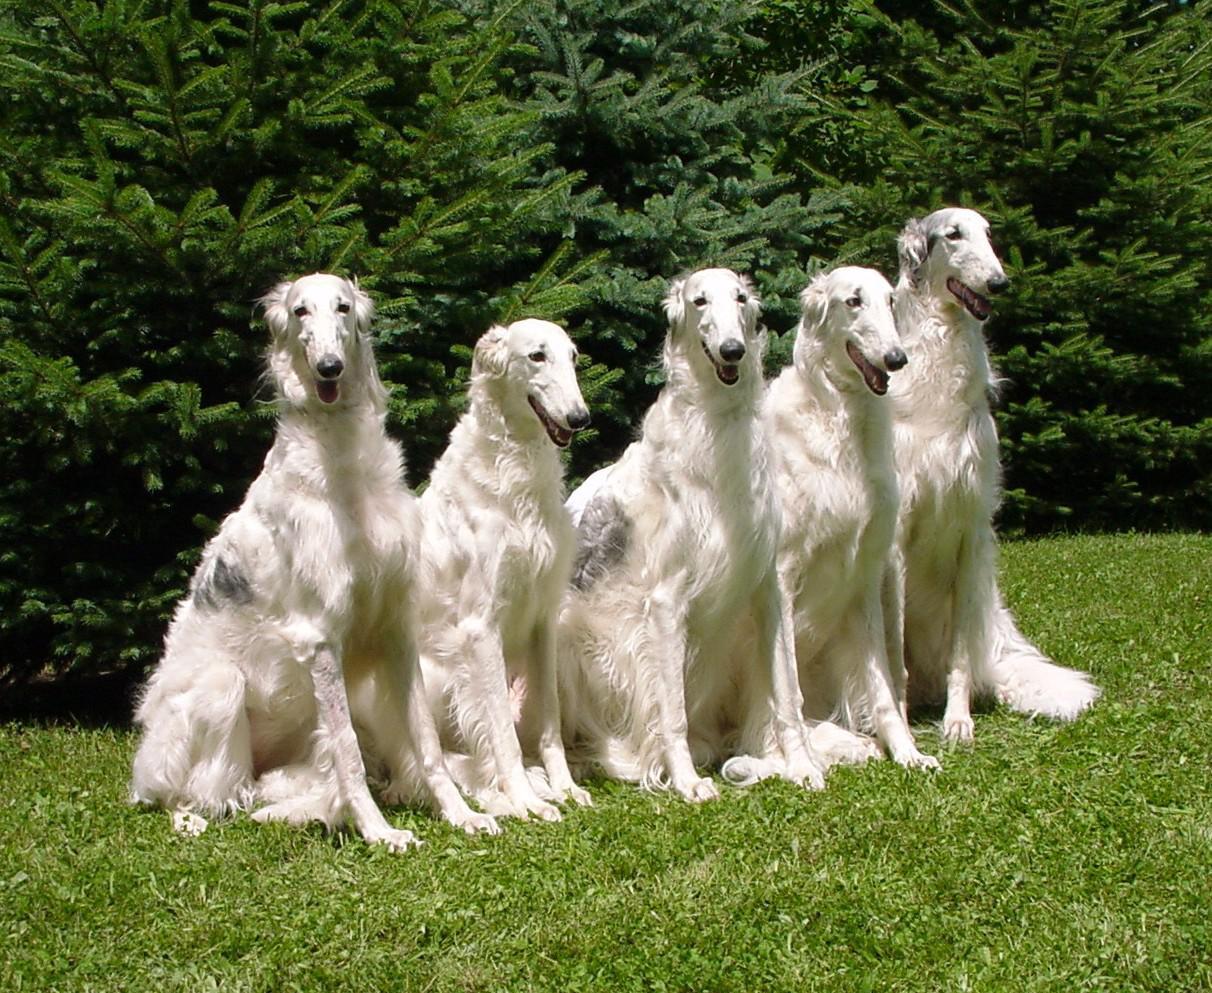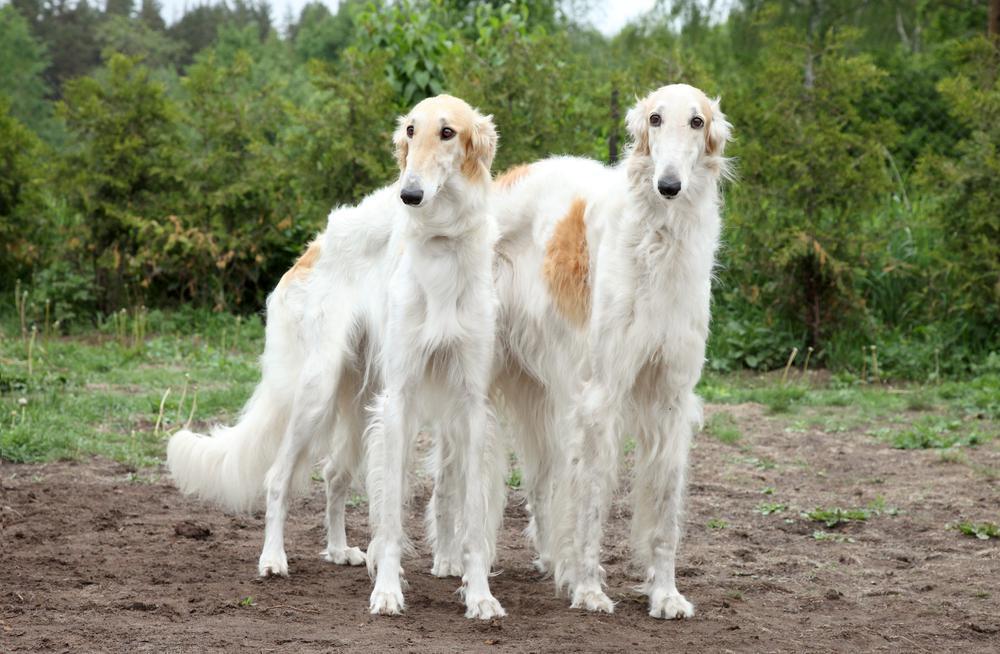The first image is the image on the left, the second image is the image on the right. For the images displayed, is the sentence "One of the images contains exactly three dogs." factually correct? Answer yes or no. No. 